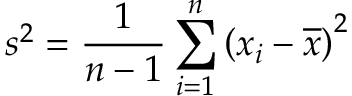<formula> <loc_0><loc_0><loc_500><loc_500>s ^ { 2 } = { \frac { 1 } { n - 1 } } \sum _ { i = 1 } ^ { n } \left ( x _ { i } - { \overline { x } } \right ) ^ { 2 }</formula> 